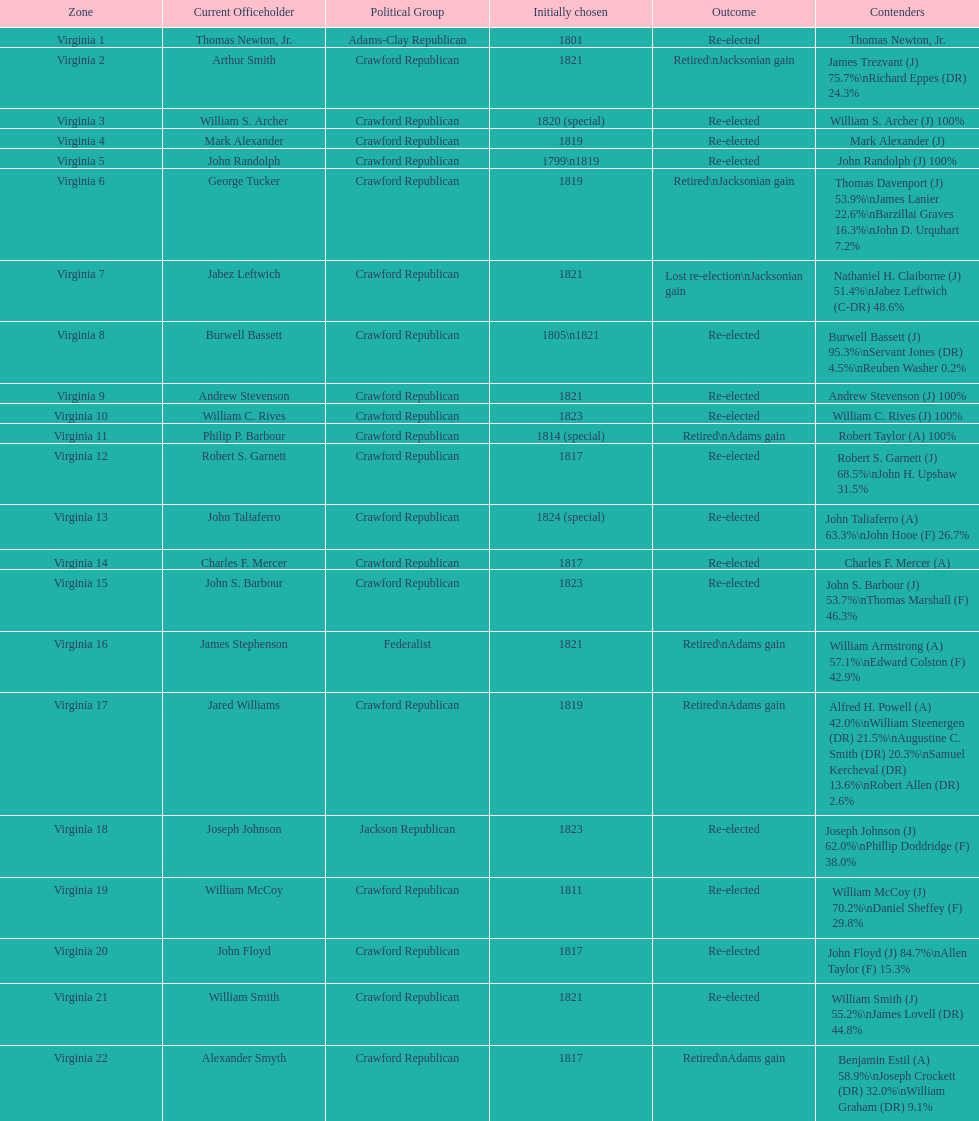Tell me the number of people first elected in 1817. 4. 